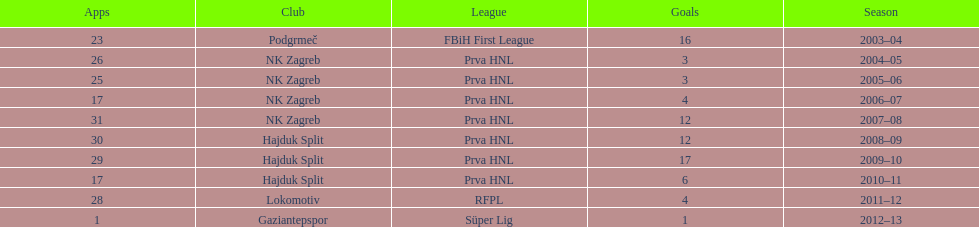Did ibricic score more or less goals in his 3 seasons with hajduk split when compared to his 4 seasons with nk zagreb? More. 